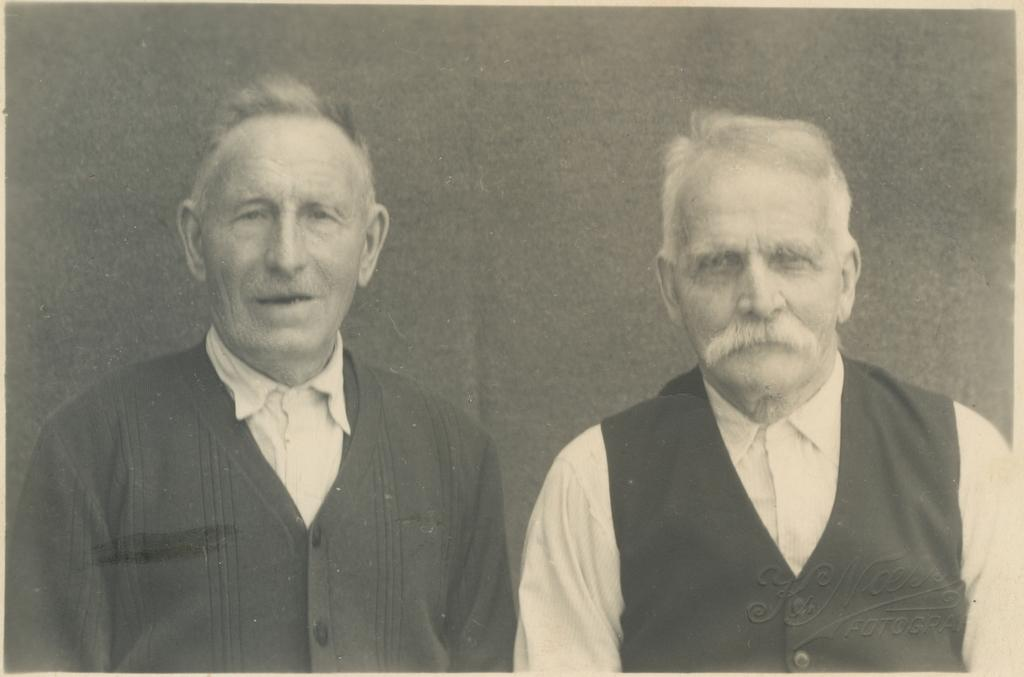What is the color scheme of the image? The image is black and white. How many people are present in the image? There are two persons in the image. What can be seen in the background of the image? There is a wall in the background of the image. What type of poison is being used by the person on the left in the image? There is no poison or indication of poison use in the image; it features two persons and a wall in the background. What is the chin length of the person on the right in the image? There is no measurement of chin length provided in the image, as it is a black and white photograph of two persons and a wall in the background. 